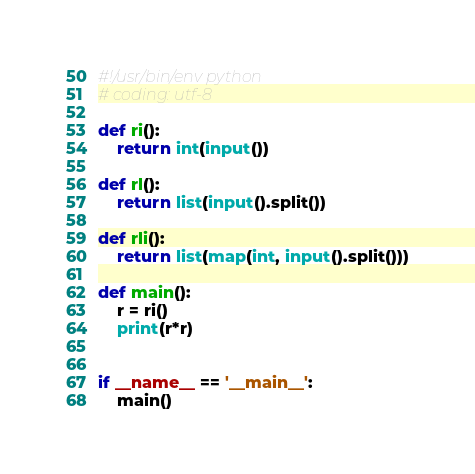<code> <loc_0><loc_0><loc_500><loc_500><_Python_>#!/usr/bin/env python
# coding: utf-8

def ri():
    return int(input())

def rl():
    return list(input().split())

def rli():
    return list(map(int, input().split()))

def main():
    r = ri()
    print(r*r)


if __name__ == '__main__':
    main()
</code> 